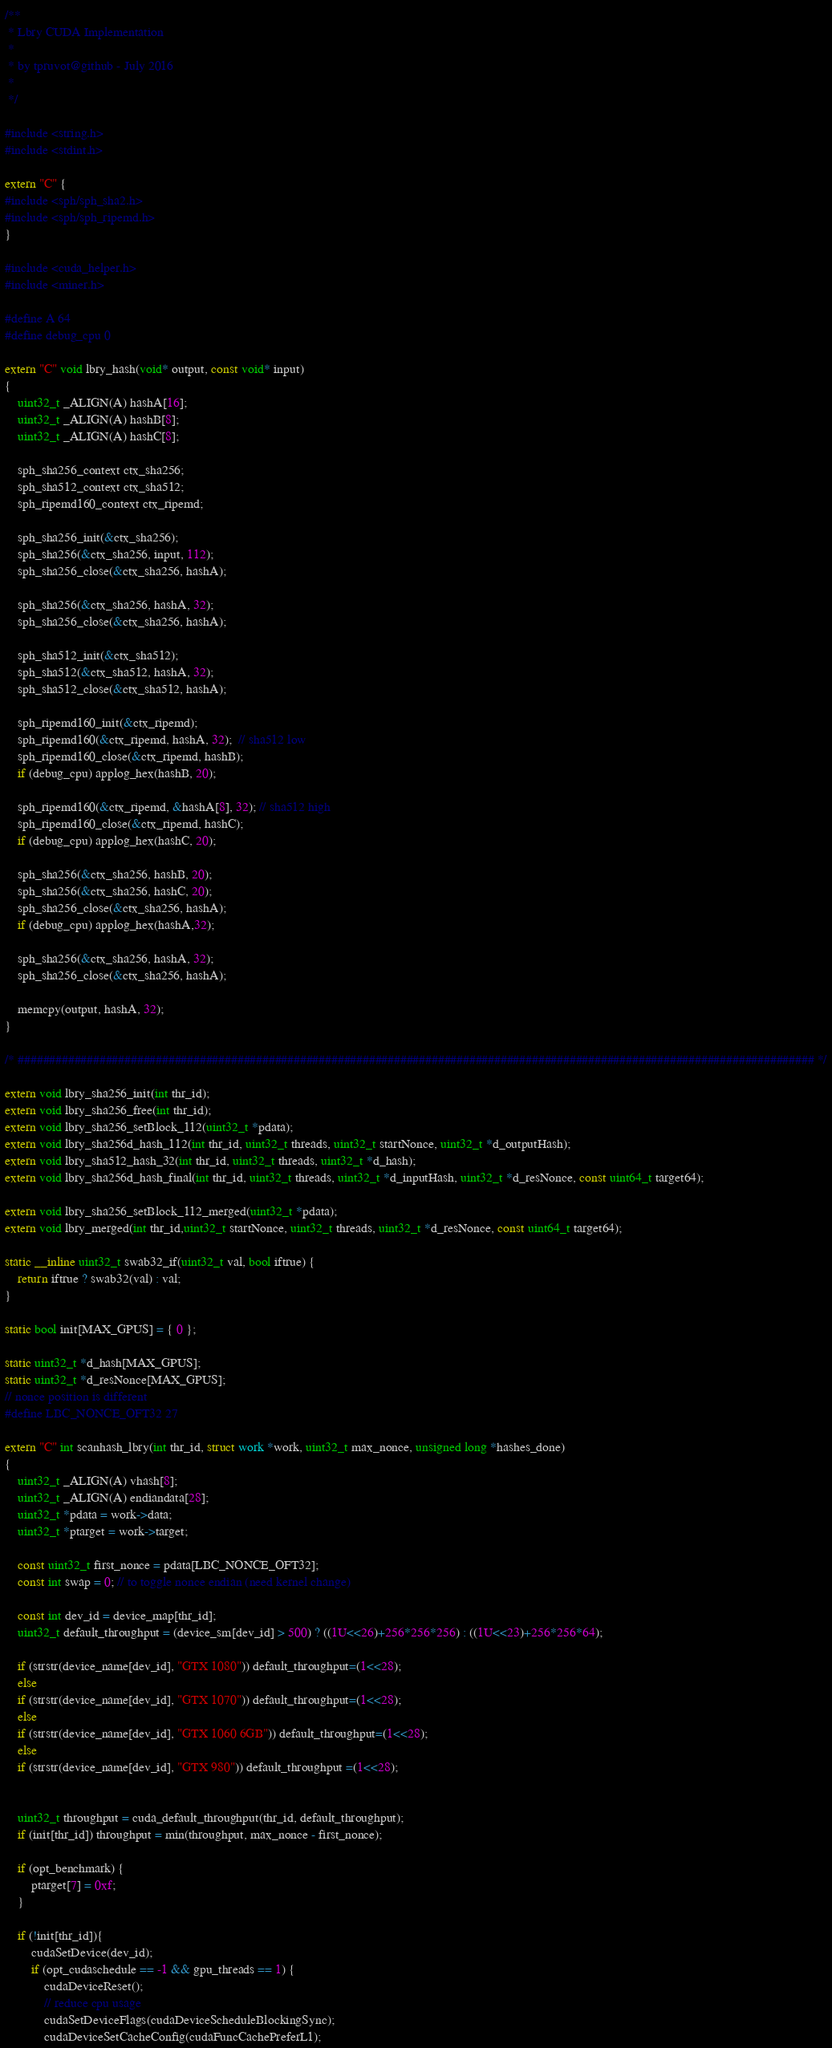<code> <loc_0><loc_0><loc_500><loc_500><_Cuda_>/**
 * Lbry CUDA Implementation
 *
 * by tpruvot@github - July 2016
 *
 */

#include <string.h>
#include <stdint.h>

extern "C" {
#include <sph/sph_sha2.h>
#include <sph/sph_ripemd.h>
}

#include <cuda_helper.h>
#include <miner.h>

#define A 64
#define debug_cpu 0

extern "C" void lbry_hash(void* output, const void* input)
{
	uint32_t _ALIGN(A) hashA[16];
	uint32_t _ALIGN(A) hashB[8];
	uint32_t _ALIGN(A) hashC[8];

	sph_sha256_context ctx_sha256;
	sph_sha512_context ctx_sha512;
	sph_ripemd160_context ctx_ripemd;

	sph_sha256_init(&ctx_sha256);
	sph_sha256(&ctx_sha256, input, 112);
	sph_sha256_close(&ctx_sha256, hashA);

	sph_sha256(&ctx_sha256, hashA, 32);
	sph_sha256_close(&ctx_sha256, hashA);

	sph_sha512_init(&ctx_sha512);
	sph_sha512(&ctx_sha512, hashA, 32);
	sph_sha512_close(&ctx_sha512, hashA);

	sph_ripemd160_init(&ctx_ripemd);
	sph_ripemd160(&ctx_ripemd, hashA, 32);  // sha512 low
	sph_ripemd160_close(&ctx_ripemd, hashB);
	if (debug_cpu) applog_hex(hashB, 20);

	sph_ripemd160(&ctx_ripemd, &hashA[8], 32); // sha512 high
	sph_ripemd160_close(&ctx_ripemd, hashC);
	if (debug_cpu) applog_hex(hashC, 20);

	sph_sha256(&ctx_sha256, hashB, 20);
	sph_sha256(&ctx_sha256, hashC, 20);
	sph_sha256_close(&ctx_sha256, hashA);
	if (debug_cpu) applog_hex(hashA,32);

	sph_sha256(&ctx_sha256, hashA, 32);
	sph_sha256_close(&ctx_sha256, hashA);

	memcpy(output, hashA, 32);
}

/* ############################################################################################################################### */

extern void lbry_sha256_init(int thr_id);
extern void lbry_sha256_free(int thr_id);
extern void lbry_sha256_setBlock_112(uint32_t *pdata);
extern void lbry_sha256d_hash_112(int thr_id, uint32_t threads, uint32_t startNonce, uint32_t *d_outputHash);
extern void lbry_sha512_hash_32(int thr_id, uint32_t threads, uint32_t *d_hash);
extern void lbry_sha256d_hash_final(int thr_id, uint32_t threads, uint32_t *d_inputHash, uint32_t *d_resNonce, const uint64_t target64);

extern void lbry_sha256_setBlock_112_merged(uint32_t *pdata);
extern void lbry_merged(int thr_id,uint32_t startNonce, uint32_t threads, uint32_t *d_resNonce, const uint64_t target64);

static __inline uint32_t swab32_if(uint32_t val, bool iftrue) {
	return iftrue ? swab32(val) : val;
}

static bool init[MAX_GPUS] = { 0 };

static uint32_t *d_hash[MAX_GPUS];
static uint32_t *d_resNonce[MAX_GPUS];
// nonce position is different
#define LBC_NONCE_OFT32 27

extern "C" int scanhash_lbry(int thr_id, struct work *work, uint32_t max_nonce, unsigned long *hashes_done)
{
	uint32_t _ALIGN(A) vhash[8];
	uint32_t _ALIGN(A) endiandata[28];
	uint32_t *pdata = work->data;
	uint32_t *ptarget = work->target;

	const uint32_t first_nonce = pdata[LBC_NONCE_OFT32];
	const int swap = 0; // to toggle nonce endian (need kernel change)

	const int dev_id = device_map[thr_id];
	uint32_t default_throughput = (device_sm[dev_id] > 500) ? ((1U<<26)+256*256*256) : ((1U<<23)+256*256*64);
	
	if (strstr(device_name[dev_id], "GTX 1080")) default_throughput=(1<<28);
	else 
	if (strstr(device_name[dev_id], "GTX 1070")) default_throughput=(1<<28);
	else 
	if (strstr(device_name[dev_id], "GTX 1060 6GB")) default_throughput=(1<<28);	
	else 
	if (strstr(device_name[dev_id], "GTX 980")) default_throughput =(1<<28);
	

	uint32_t throughput = cuda_default_throughput(thr_id, default_throughput);
	if (init[thr_id]) throughput = min(throughput, max_nonce - first_nonce);

	if (opt_benchmark) {
		ptarget[7] = 0xf;
	}

	if (!init[thr_id]){
		cudaSetDevice(dev_id);
		if (opt_cudaschedule == -1 && gpu_threads == 1) {
			cudaDeviceReset();
			// reduce cpu usage
			cudaSetDeviceFlags(cudaDeviceScheduleBlockingSync);
			cudaDeviceSetCacheConfig(cudaFuncCachePreferL1);</code> 